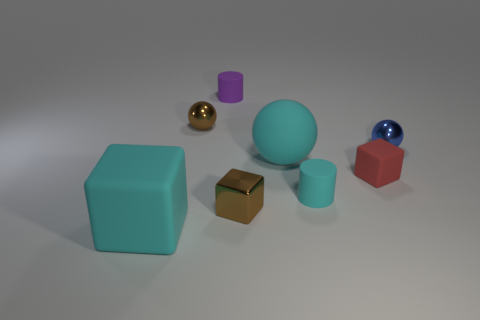How many other objects are the same material as the brown block?
Keep it short and to the point. 2. The brown shiny thing that is behind the small cyan rubber cylinder has what shape?
Keep it short and to the point. Sphere. There is a tiny block to the right of the tiny cylinder in front of the tiny blue shiny thing; what is it made of?
Ensure brevity in your answer.  Rubber. Are there more tiny purple matte objects that are on the right side of the large sphere than tiny metal spheres?
Offer a terse response. No. What number of other things are the same color as the tiny rubber block?
Give a very brief answer. 0. The red matte thing that is the same size as the brown metal cube is what shape?
Your response must be concise. Cube. What number of purple cylinders are to the left of the small rubber cylinder to the left of the big rubber thing that is to the right of the big matte block?
Give a very brief answer. 0. How many metallic objects are cyan cylinders or red cubes?
Offer a terse response. 0. What is the color of the ball that is both behind the big cyan rubber ball and to the right of the small purple rubber thing?
Offer a very short reply. Blue. Do the rubber block on the right side of the cyan block and the cyan matte cylinder have the same size?
Make the answer very short. Yes. 